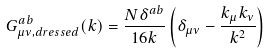<formula> <loc_0><loc_0><loc_500><loc_500>& G ^ { a b } _ { \mu \nu , d r e s s e d } ( k ) = \frac { N \delta ^ { a b } } { 1 6 k } \left ( \delta _ { \mu \nu } - \frac { k _ { \mu } k _ { \nu } } { k ^ { 2 } } \right )</formula> 